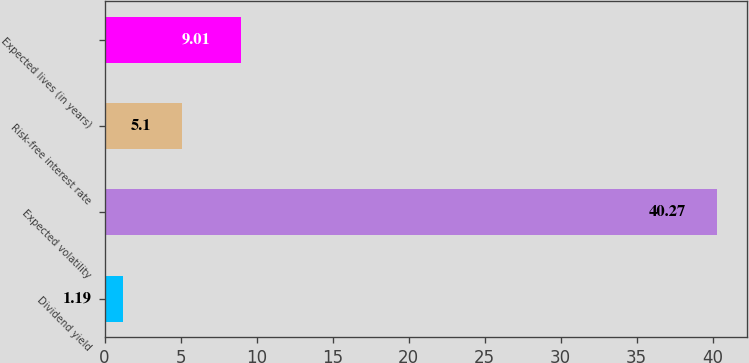<chart> <loc_0><loc_0><loc_500><loc_500><bar_chart><fcel>Dividend yield<fcel>Expected volatility<fcel>Risk-free interest rate<fcel>Expected lives (in years)<nl><fcel>1.19<fcel>40.27<fcel>5.1<fcel>9.01<nl></chart> 